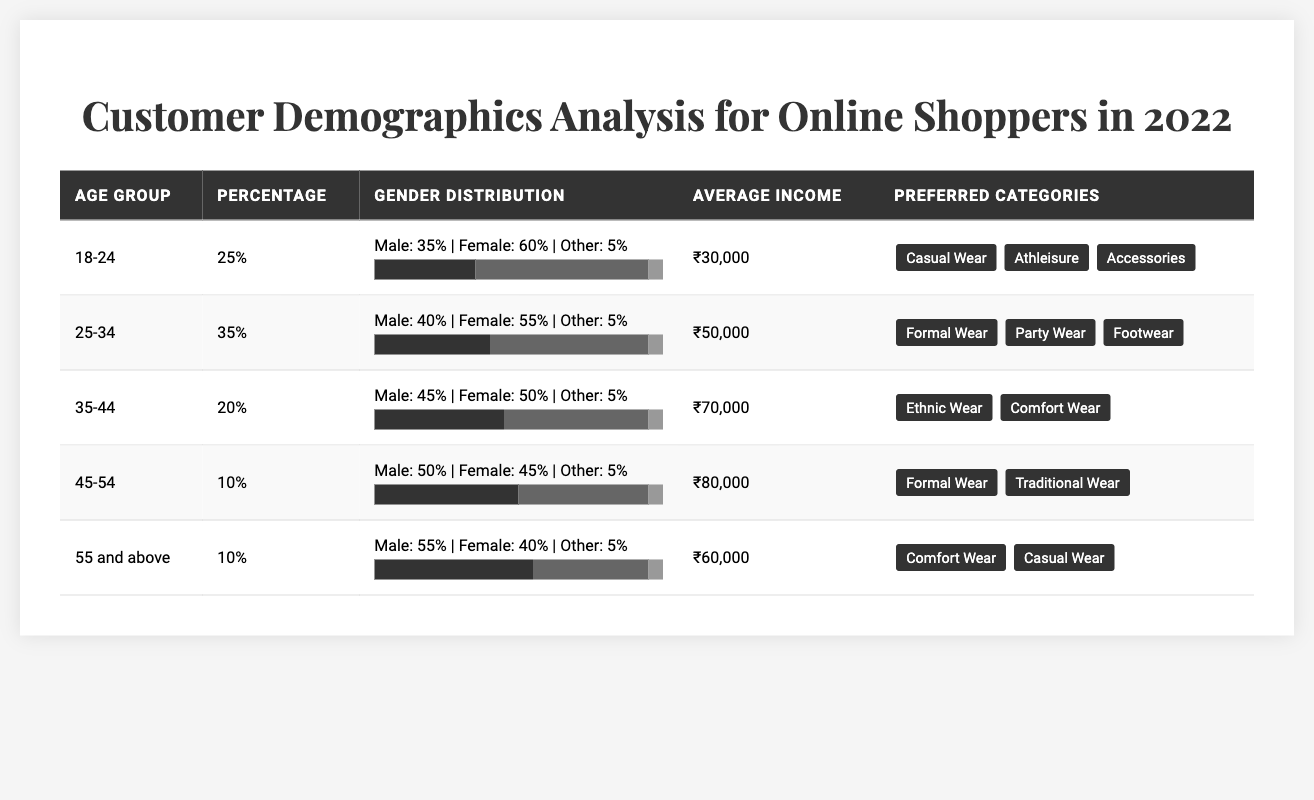What is the percentage of customers aged 25-34? The table shows that the age group 25-34 has a percentage of 35%.
Answer: 35% Which age group has the highest average income? From the table, the age group 45-54 has the highest average income of ₹80,000.
Answer: 45-54 How many preferred categories does the age group 18-24 have? The age group 18-24 has three preferred categories listed: Casual Wear, Athleisure, and Accessories.
Answer: 3 What percentage of online shoppers are between the ages of 35 and 54? The percentages for the age group 35-44 is 20% and 45-54 is 10%, so the total is 20% + 10% = 30%.
Answer: 30% Is there a gender distribution in the age group 55 and above where males constitute more than 50%? The gender distribution for age group 55 and above shows males at 55%, which is indeed more than 50%.
Answer: Yes What is the average income of the age group with the most preferred categories? Age group 18-24 has the most preferred categories at three and has an average income of ₹30,000.
Answer: ₹30,000 Which age group has the lowest percentage of online shoppers? The age group 45-54 and 55 and above both have the lowest percentage at 10%.
Answer: 45-54 and 55 and above How does the male gender distribution compare between the age groups 25-34 and 35-44? The age group 25-34 has 40% male, while the age group 35-44 has 45% male, showing that 35-44 has a higher male distribution.
Answer: 35-44 has more males If I combine the preferred categories of age groups 35-44 and 45-54, how many unique categories are there? Age group 35-44 prefers Ethnic Wear and Comfort Wear, while 45-54 prefers Formal Wear and Traditional Wear. In total, the unique categories are 4 (Ethnic Wear, Comfort Wear, Formal Wear, Traditional Wear).
Answer: 4 What is the combined percentage of online shoppers from the age groups 55 and above and 45-54? The combined percentage of these two age groups is 10% + 10% = 20%.
Answer: 20% 